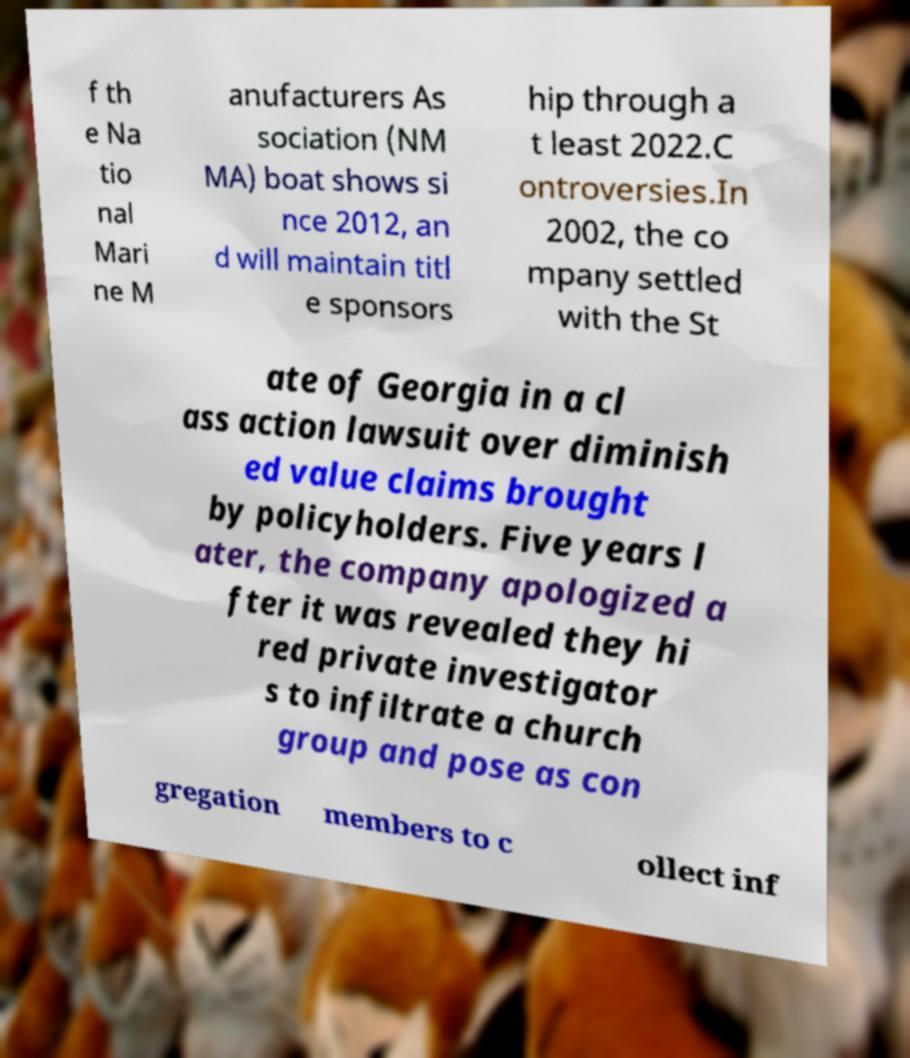There's text embedded in this image that I need extracted. Can you transcribe it verbatim? f th e Na tio nal Mari ne M anufacturers As sociation (NM MA) boat shows si nce 2012, an d will maintain titl e sponsors hip through a t least 2022.C ontroversies.In 2002, the co mpany settled with the St ate of Georgia in a cl ass action lawsuit over diminish ed value claims brought by policyholders. Five years l ater, the company apologized a fter it was revealed they hi red private investigator s to infiltrate a church group and pose as con gregation members to c ollect inf 